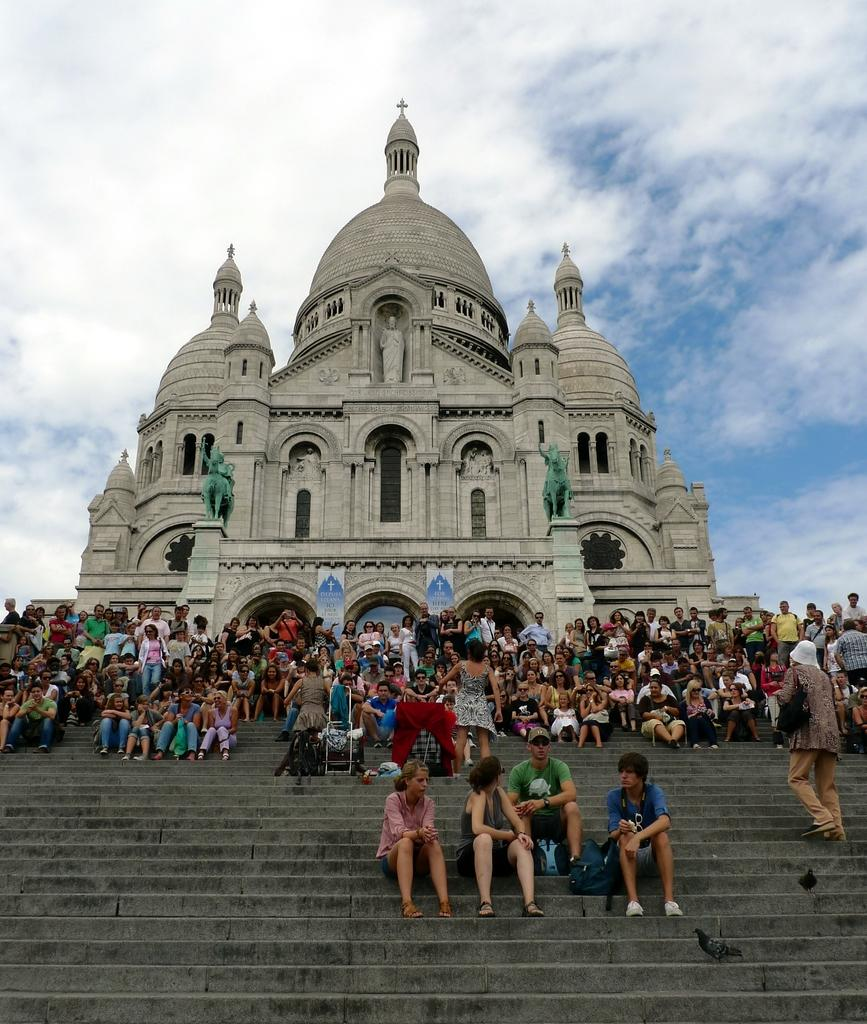What are the people in the image doing? The people in the image are sitting on the stairs. Where are the stairs located in relation to the church building? The stairs are in front of a church building. What can be seen in the sky at the top of the image? There are clouds in the sky at the top of the image. What type of humor is being displayed by the cabbage in the image? There is no cabbage present in the image, so it cannot be used to determine any type of humor. 